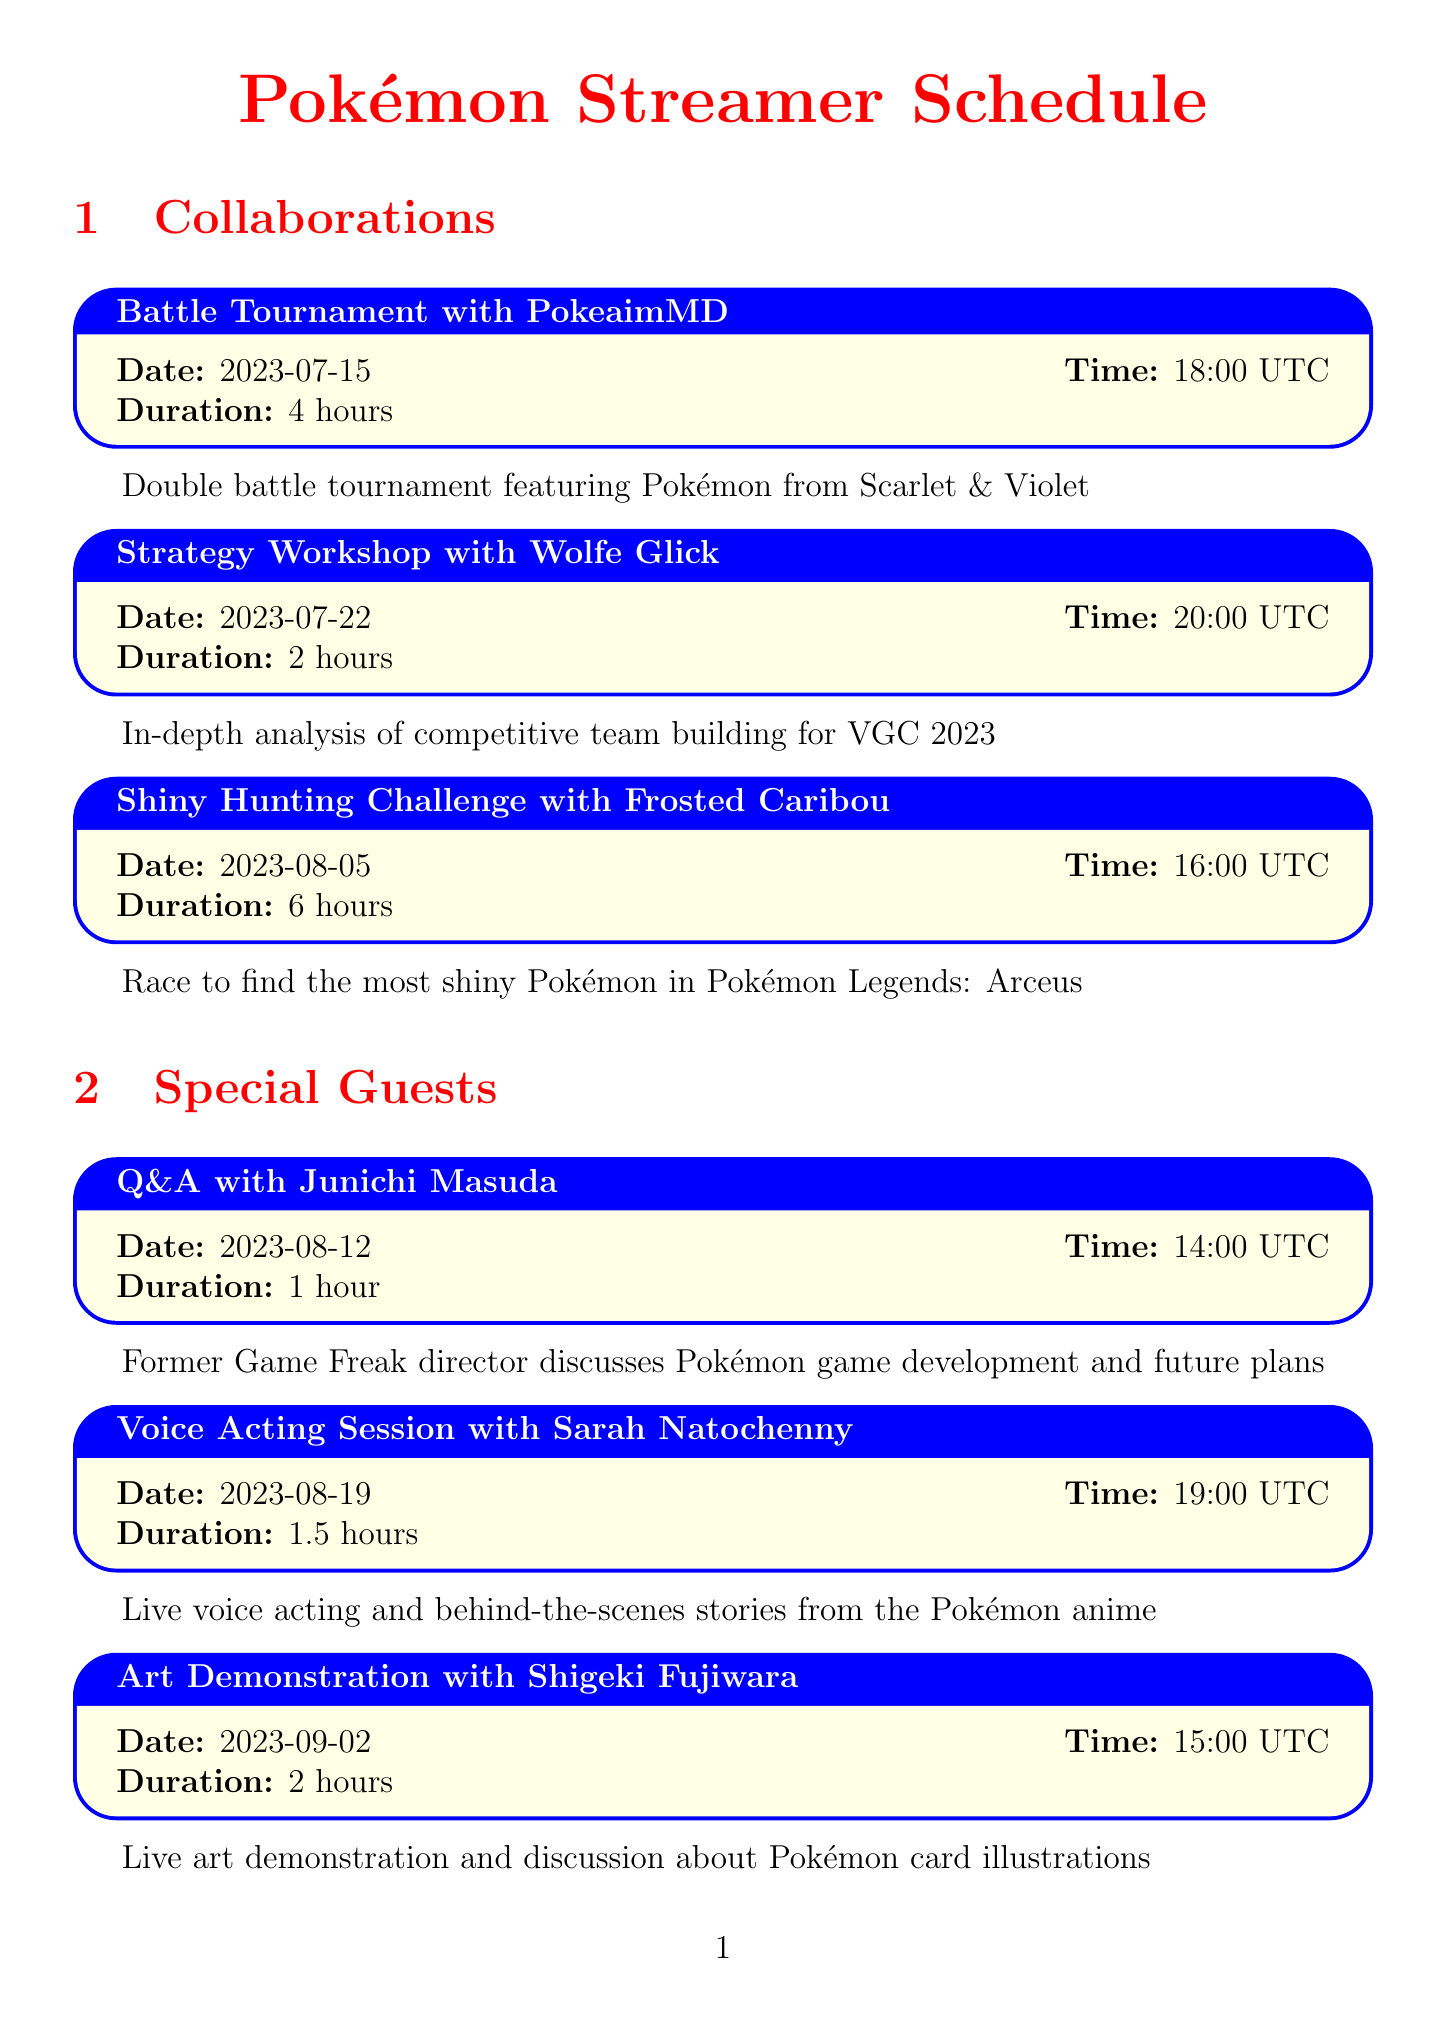What is the date of the Battle Tournament with PokeaimMD? The date for the Battle Tournament with PokeaimMD is specifically listed in the document.
Answer: 2023-07-15 How long is the Strategy Workshop with Wolfe Glick? The duration of the Strategy Workshop with Wolfe Glick is clearly mentioned as part of the event details.
Answer: 2 hours Who is the special guest on August 19th? The document names special guests along with their corresponding dates, which allows for easy retrieval of this information.
Answer: Sarah Natochenny What event occurs immediately after the Viewer Battle Royale? The schedule outlines the events chronologically, making it easy to see which event follows another in the list.
Answer: Pokémon Trivia Night How many hours is the Shiny Hunting Challenge with Frosted Caribou? The duration of the Shiny Hunting Challenge can be found directly in the event details in the document.
Answer: 6 hours What is Junichi Masuda's role? The document describes the roles of special guests, which aids in understanding who they are and their relevance to the events.
Answer: Former Game Freak director What type of event is scheduled for September 9th? The event type is explicitly stated in the schedule, allowing for straightforward identification of the event category.
Answer: Charity Stream for Pokémon Conservation Which streamer is hosting the next event after the Strategy Workshop? The sequence of events provides clarity on which streamer will host the upcoming event, revealing their involvement next.
Answer: Frosted Caribou 